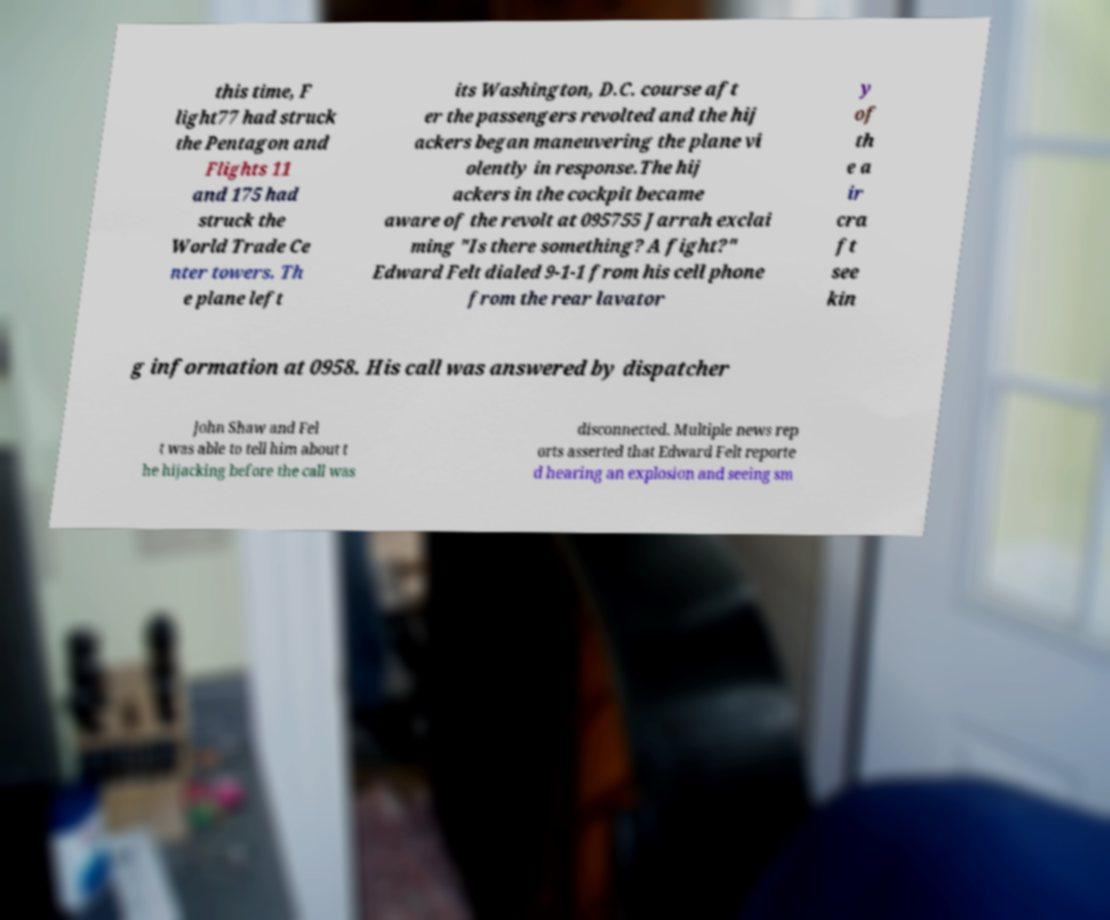Could you assist in decoding the text presented in this image and type it out clearly? this time, F light77 had struck the Pentagon and Flights 11 and 175 had struck the World Trade Ce nter towers. Th e plane left its Washington, D.C. course aft er the passengers revolted and the hij ackers began maneuvering the plane vi olently in response.The hij ackers in the cockpit became aware of the revolt at 095755 Jarrah exclai ming "Is there something? A fight?" Edward Felt dialed 9-1-1 from his cell phone from the rear lavator y of th e a ir cra ft see kin g information at 0958. His call was answered by dispatcher John Shaw and Fel t was able to tell him about t he hijacking before the call was disconnected. Multiple news rep orts asserted that Edward Felt reporte d hearing an explosion and seeing sm 